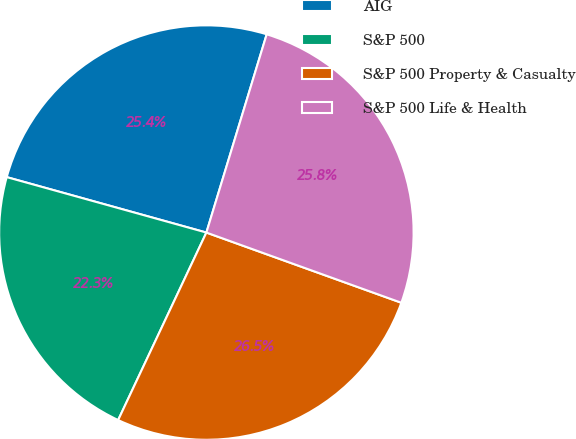<chart> <loc_0><loc_0><loc_500><loc_500><pie_chart><fcel>AIG<fcel>S&P 500<fcel>S&P 500 Property & Casualty<fcel>S&P 500 Life & Health<nl><fcel>25.39%<fcel>22.31%<fcel>26.5%<fcel>25.8%<nl></chart> 